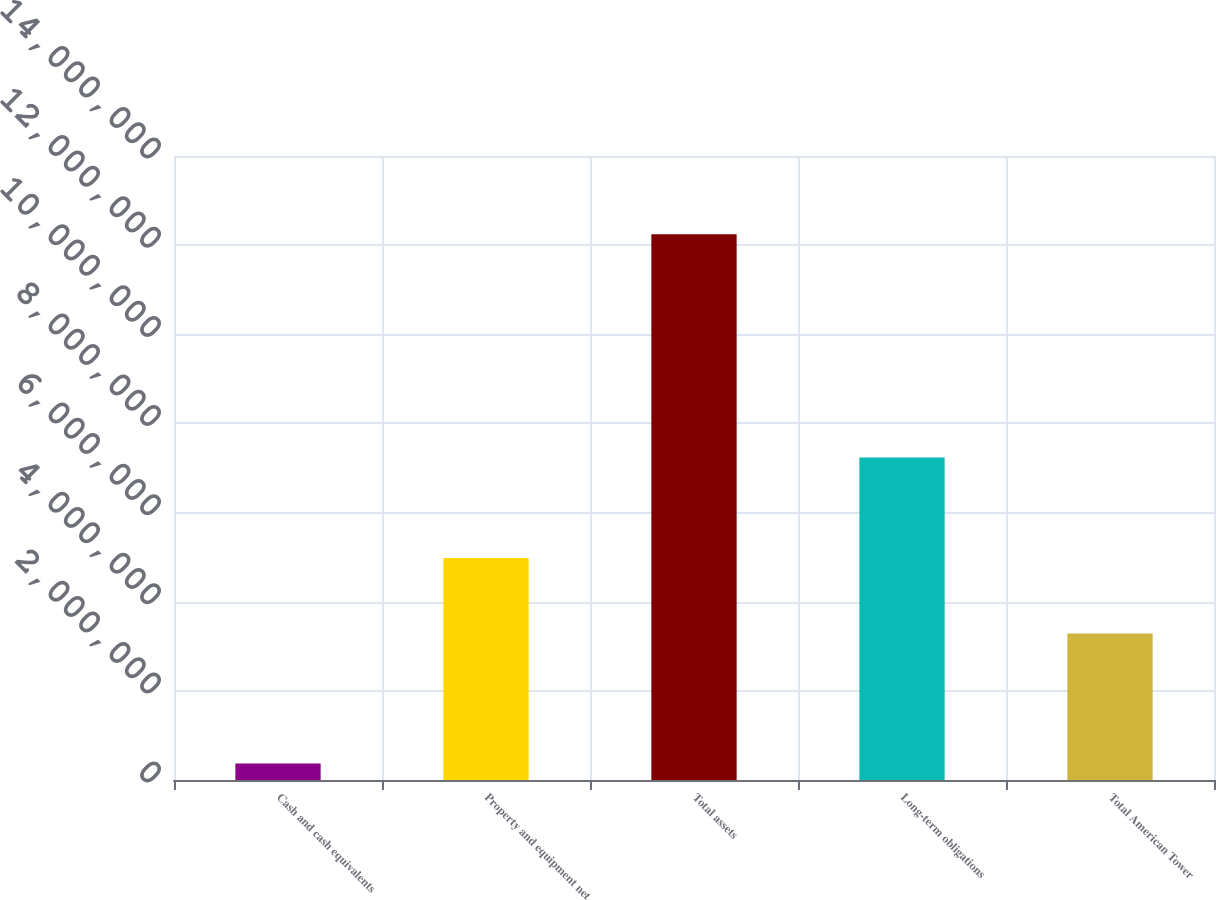Convert chart. <chart><loc_0><loc_0><loc_500><loc_500><bar_chart><fcel>Cash and cash equivalents<fcel>Property and equipment net<fcel>Total assets<fcel>Long-term obligations<fcel>Total American Tower<nl><fcel>372406<fcel>4.98172e+06<fcel>1.22424e+07<fcel>7.23631e+06<fcel>3.28722e+06<nl></chart> 